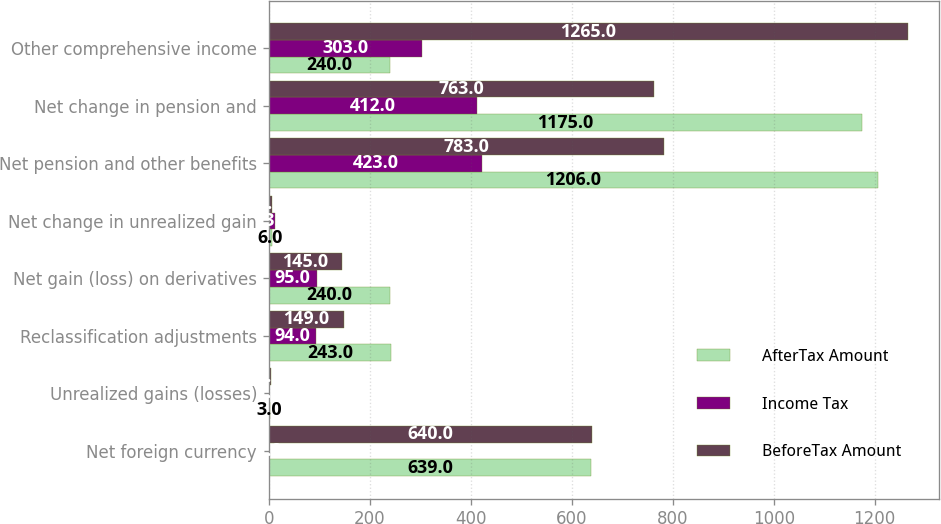Convert chart to OTSL. <chart><loc_0><loc_0><loc_500><loc_500><stacked_bar_chart><ecel><fcel>Net foreign currency<fcel>Unrealized gains (losses)<fcel>Reclassification adjustments<fcel>Net gain (loss) on derivatives<fcel>Net change in unrealized gain<fcel>Net pension and other benefits<fcel>Net change in pension and<fcel>Other comprehensive income<nl><fcel>AfterTax Amount<fcel>639<fcel>3<fcel>243<fcel>240<fcel>6<fcel>1206<fcel>1175<fcel>240<nl><fcel>Income Tax<fcel>1<fcel>1<fcel>94<fcel>95<fcel>13<fcel>423<fcel>412<fcel>303<nl><fcel>BeforeTax Amount<fcel>640<fcel>4<fcel>149<fcel>145<fcel>7<fcel>783<fcel>763<fcel>1265<nl></chart> 